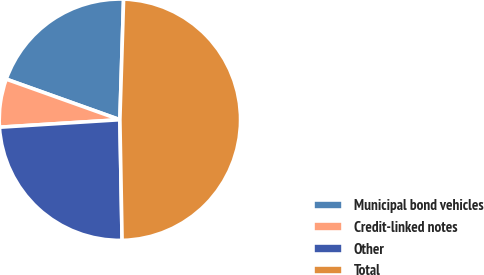<chart> <loc_0><loc_0><loc_500><loc_500><pie_chart><fcel>Municipal bond vehicles<fcel>Credit-linked notes<fcel>Other<fcel>Total<nl><fcel>20.03%<fcel>6.45%<fcel>24.3%<fcel>49.22%<nl></chart> 